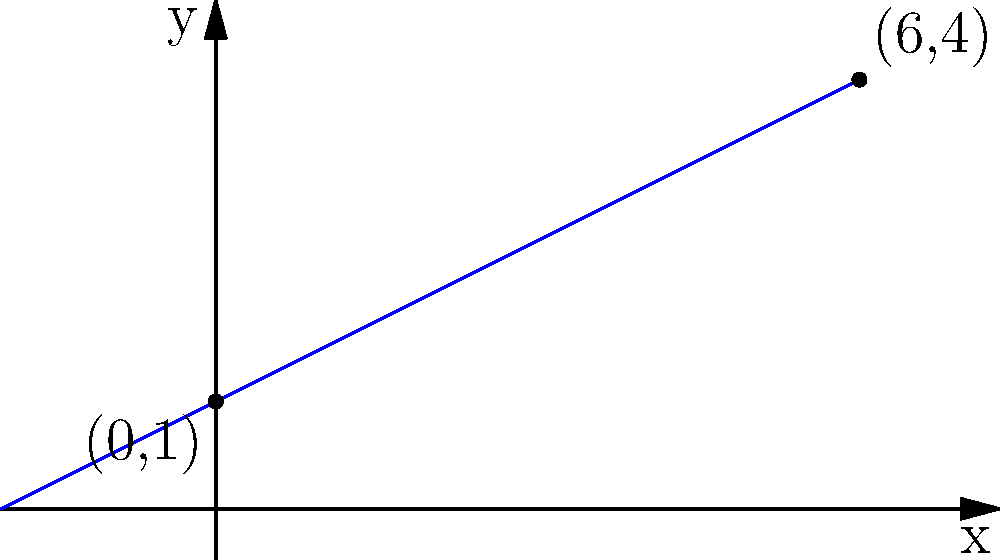In Tyler Perry's "Madea's Family Reunion," Vanessa's character arc shows significant personal growth. If we represent her journey on a graph where the x-axis represents time (in months) and the y-axis represents her level of self-confidence, we can draw a line from the point (0,1) to (6,4). What is the slope of this line, symbolizing Vanessa's rate of personal growth? To find the slope of the line representing Vanessa's personal growth, we'll use the slope formula:

$$ \text{Slope} = \frac{y_2 - y_1}{x_2 - x_1} $$

Where $(x_1, y_1)$ is the starting point and $(x_2, y_2)$ is the ending point.

Given:
- Starting point: (0, 1)
- Ending point: (6, 4)

Let's plug these values into the formula:

$$ \text{Slope} = \frac{4 - 1}{6 - 0} = \frac{3}{6} $$

Simplifying the fraction:

$$ \frac{3}{6} = \frac{1}{2} = 0.5 $$

Therefore, the slope of the line is 0.5, which represents Vanessa's rate of personal growth over the 6-month period.
Answer: 0.5 